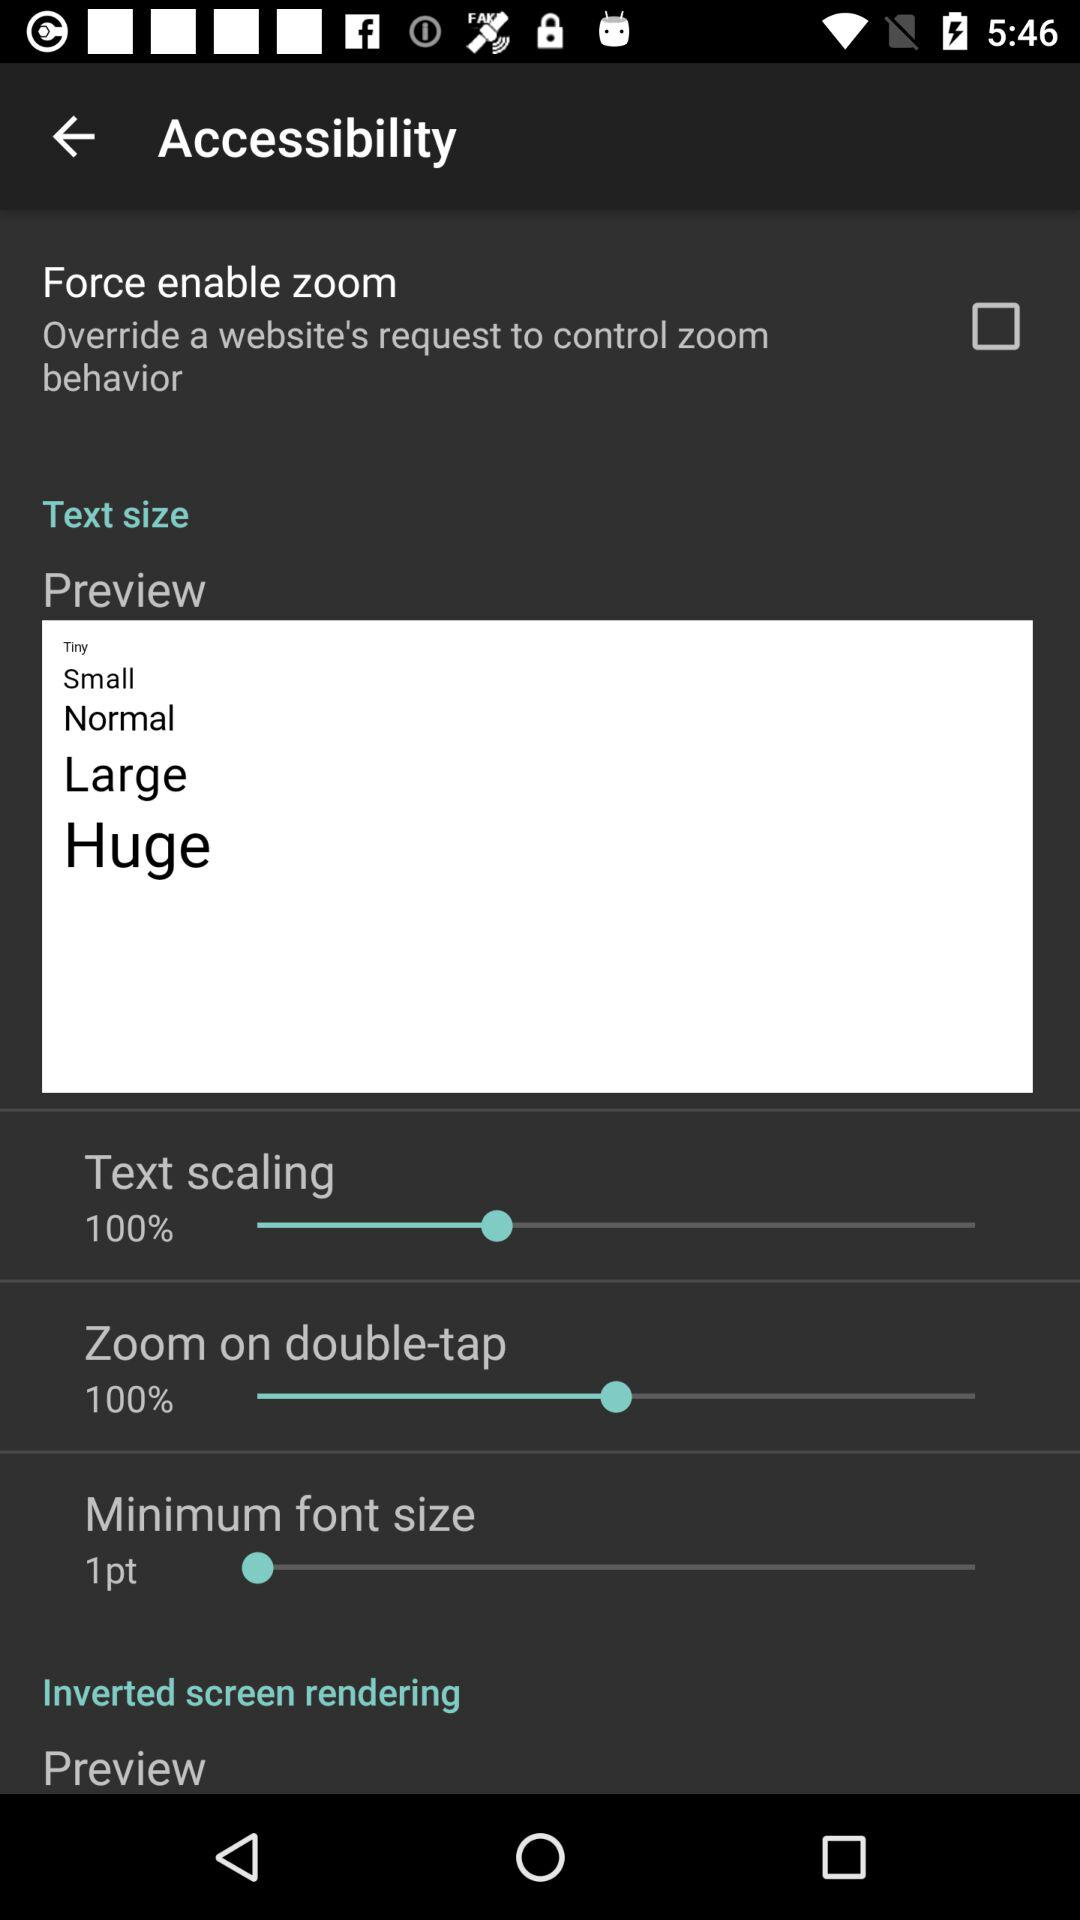What is the status of "Force enable zoom"? The status is "off". 